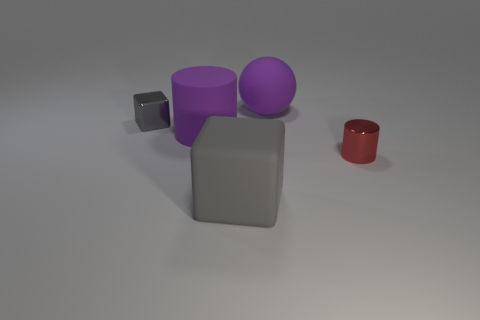Add 1 large gray matte objects. How many objects exist? 6 Subtract all blocks. How many objects are left? 3 Add 3 large gray metallic spheres. How many large gray metallic spheres exist? 3 Subtract all purple cylinders. How many cylinders are left? 1 Subtract 0 purple blocks. How many objects are left? 5 Subtract 1 blocks. How many blocks are left? 1 Subtract all cyan blocks. Subtract all yellow cylinders. How many blocks are left? 2 Subtract all tiny yellow shiny cubes. Subtract all large matte balls. How many objects are left? 4 Add 4 tiny gray objects. How many tiny gray objects are left? 5 